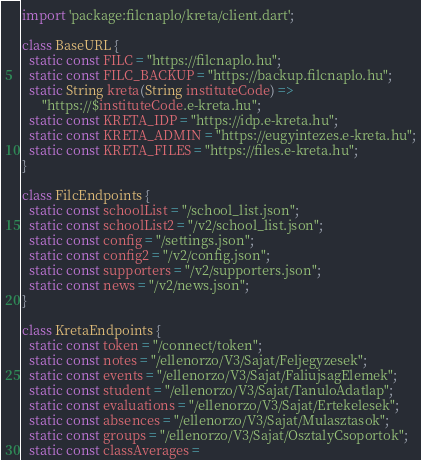Convert code to text. <code><loc_0><loc_0><loc_500><loc_500><_Dart_>import 'package:filcnaplo/kreta/client.dart';

class BaseURL {
  static const FILC = "https://filcnaplo.hu";
  static const FILC_BACKUP = "https://backup.filcnaplo.hu";
  static String kreta(String instituteCode) =>
      "https://$instituteCode.e-kreta.hu";
  static const KRETA_IDP = "https://idp.e-kreta.hu";
  static const KRETA_ADMIN = "https://eugyintezes.e-kreta.hu";
  static const KRETA_FILES = "https://files.e-kreta.hu";
}

class FilcEndpoints {
  static const schoolList = "/school_list.json";
  static const schoolList2 = "/v2/school_list.json";
  static const config = "/settings.json";
  static const config2 = "/v2/config.json";
  static const supporters = "/v2/supporters.json";
  static const news = "/v2/news.json";
}

class KretaEndpoints {
  static const token = "/connect/token";
  static const notes = "/ellenorzo/V3/Sajat/Feljegyzesek";
  static const events = "/ellenorzo/V3/Sajat/FaliujsagElemek";
  static const student = "/ellenorzo/V3/Sajat/TanuloAdatlap";
  static const evaluations = "/ellenorzo/V3/Sajat/Ertekelesek";
  static const absences = "/ellenorzo/V3/Sajat/Mulasztasok";
  static const groups = "/ellenorzo/V3/Sajat/OsztalyCsoportok";
  static const classAverages =</code> 